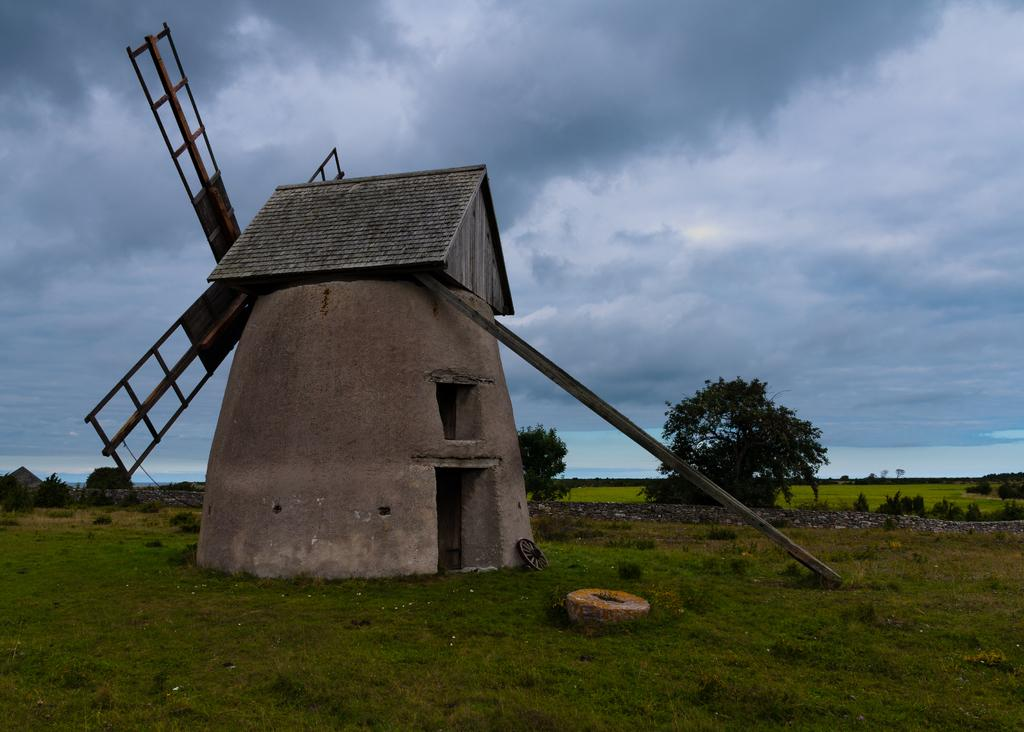What is the main subject in the middle of the image? There is a windmill in the middle of the image. What can be seen behind the windmill? There are trees behind the windmill. How would you describe the sky in the image? The sky is cloudy at the top of the image. Can you hear the windmill crying in the image? There is no sound or indication of crying in the image; it is a still image of a windmill and trees. 